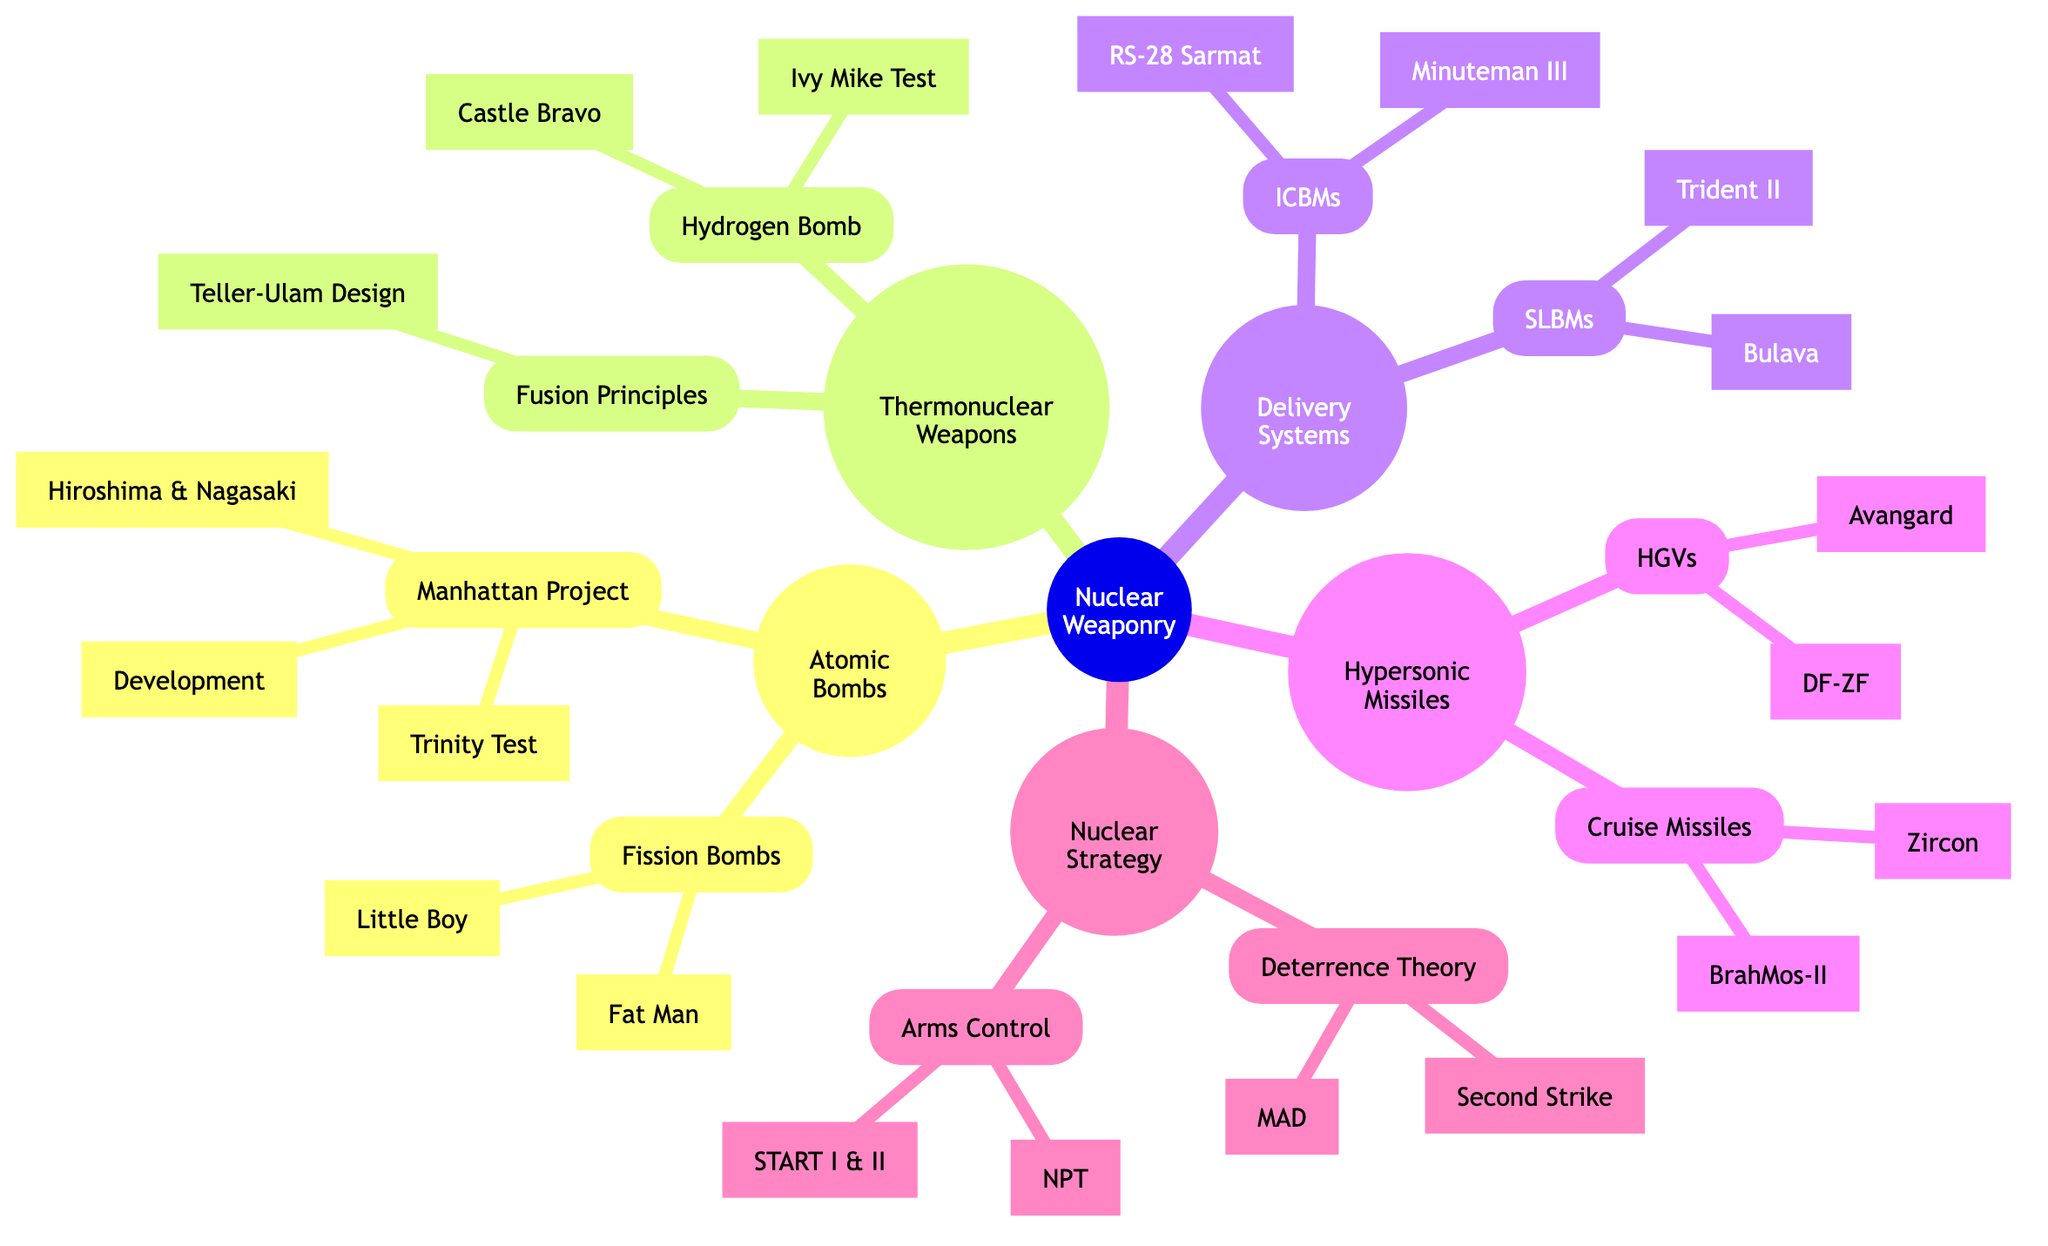What are the two major types of bombs listed under Atomic Bombs? The diagram shows two major classifications under Atomic Bombs, which are "Fission Bombs" and "Thermonuclear Weapons". However, since the question specifically requests the types under Atomic Bombs, we focus on "Fission Bombs" and their subbranch names.
Answer: Fission Bombs How many subbranches are under Nuclear Strategy? The Nuclear Strategy node has two subbranches: "Deterrence Theory" and "Arms Control Agreements". Counting these gives a total of two subbranches under Nuclear Strategy.
Answer: 2 Which test is associated with the Hydrogen Bomb? The Hydrogen Bomb subbranch lists two significant tests: "Ivy Mike Test" and "Castle Bravo". The question specifies to name one, both tests are correct, but typically Ivy Mike is often first mentioned in discussions.
Answer: Ivy Mike Test What is the name of the missile classified under Intercontinental Ballistic Missiles? The branch labeled ICBMs lists "Minuteman III" and "RS-28 Sarmat". The question asks for one name; Minuteman III is often the most recognized.
Answer: Minuteman III What principle is used in Fusion Weapons? In the Fusion Principles subbranch, the only item mentioned is "Teller-Ulam Design", which represents the principle behind these fusion weapons.
Answer: Teller-Ulam Design Which missile is listed as a Hypersonic Glide Vehicle? The Hypersonic Missiles branch has a category for Hypersonic Glide Vehicles, where "Avangard" is specifically listed as one such example.
Answer: Avangard How many tests are mentioned under Thermonuclear Weapons? The "Hydrogen Bomb" category has two subbranches: "Ivy Mike Test" and "Castle Bravo". Adding these gives a total of two tests mentioned.
Answer: 2 What are the two components of Deterrence Theory? Under the Deterrence Theory subbranch, there are two listed components: "Mutual Assured Destruction (MAD)" and "Second Strike Capability". Both are critical for understanding the theory.
Answer: Mutual Assured Destruction (MAD) and Second Strike Capability What delivery system is associated with the Trident II? The "Trident II" is listed under the subbranch "Submarine-Launched Ballistic Missiles (SLBMs)", which identifies its specific category within delivery systems.
Answer: Submarine-Launched Ballistic Missiles (SLBMs) 